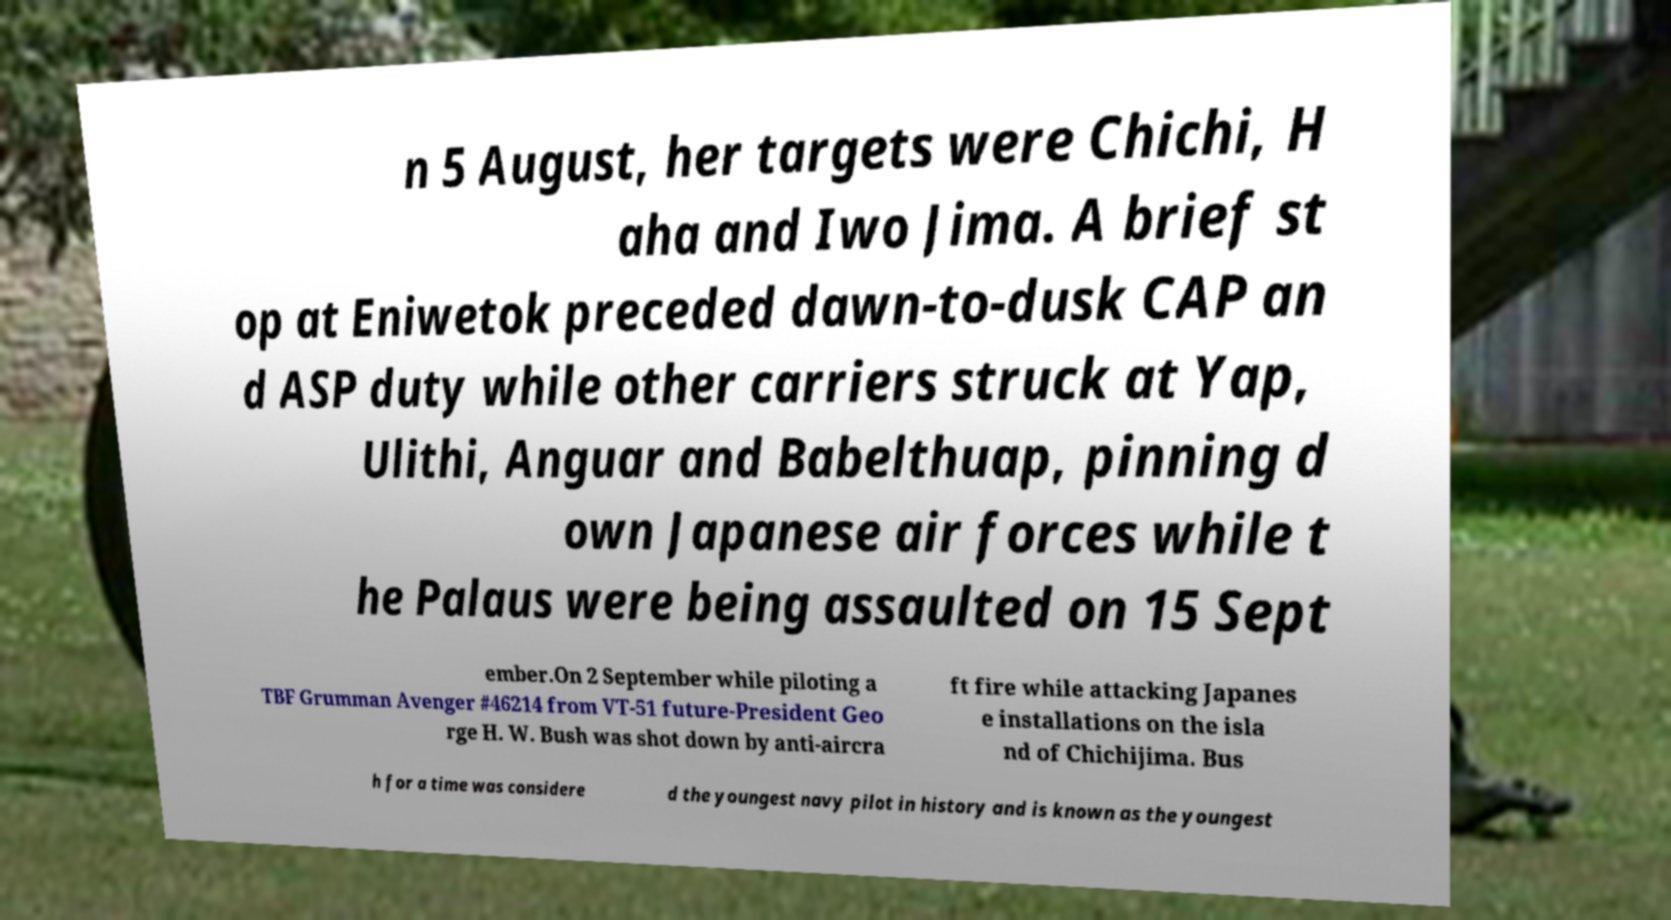I need the written content from this picture converted into text. Can you do that? n 5 August, her targets were Chichi, H aha and Iwo Jima. A brief st op at Eniwetok preceded dawn-to-dusk CAP an d ASP duty while other carriers struck at Yap, Ulithi, Anguar and Babelthuap, pinning d own Japanese air forces while t he Palaus were being assaulted on 15 Sept ember.On 2 September while piloting a TBF Grumman Avenger #46214 from VT-51 future-President Geo rge H. W. Bush was shot down by anti-aircra ft fire while attacking Japanes e installations on the isla nd of Chichijima. Bus h for a time was considere d the youngest navy pilot in history and is known as the youngest 